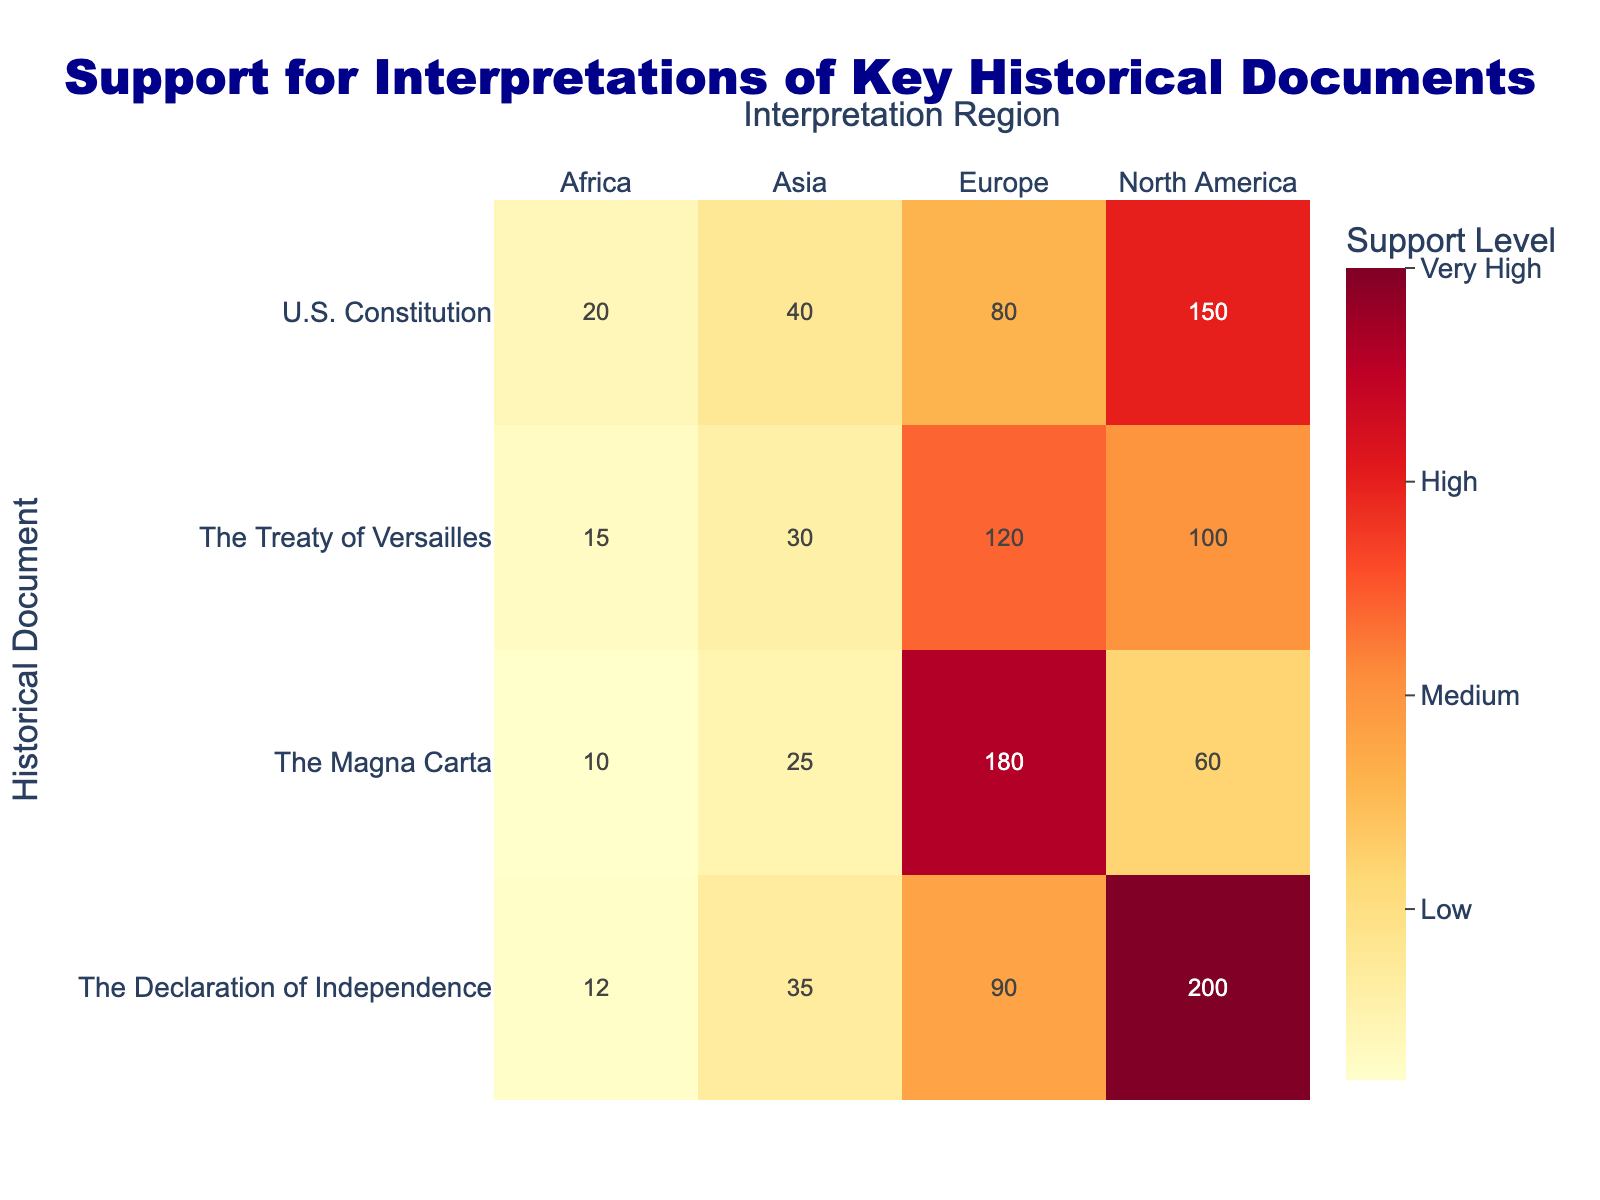What is the highest level of support for the U.S. Constitution, and which region is it from? The highest support for the U.S. Constitution is 150, coming from North America. This can be found directly in the table under the Support for Interpretation column corresponding to the U.S. Constitution row.
Answer: 150, North America What is the total support for the Magna Carta across all regions? To find the total support for the Magna Carta, we sum the support values from all regions: 60 (North America) + 180 (Europe) + 25 (Asia) + 10 (Africa) = 275.
Answer: 275 Is there more support for The Declaration of Independence in Asia than in Africa? The support for The Declaration of Independence in Asia is 35, while in Africa it is 12. Since 35 is greater than 12, the answer to the question is yes.
Answer: Yes What is the average support for the Treaty of Versailles across the four regions? The support values for the Treaty of Versailles are: 100 (North America), 120 (Europe), 30 (Asia), and 15 (Africa). The total is 100 + 120 + 30 + 15 = 265. There are 4 regions, so the average is 265 / 4 = 66.25.
Answer: 66.25 Which historical document has the most opposition to interpretation in North America? The historical document with the most opposition in North America is The Treaty of Versailles, which has an opposition value of 60. We compare the opposition values for all documents in North America and find that 60 is the highest.
Answer: The Treaty of Versailles What is the difference in support for interpretations of the U.S. Constitution and The Magna Carta in Europe? In Europe, the support for the U.S. Constitution is 80 and for The Magna Carta is 180. The difference is calculated as 180 - 80 = 100.
Answer: 100 Are there more instances of support or opposition to The Magna Carta across all regions combined? First, we total the support of The Magna Carta: 60 + 180 + 25 + 10 = 275. Then, we total the opposition: 20 + 40 + 10 + 5 = 75. Since 275 (support) is greater than 75 (opposition), the answer is more support.
Answer: More support Which region shows the lowest support for The Declaration of Independence? The support values for The Declaration of Independence are: 200 (North America), 90 (Europe), 35 (Asia), and 12 (Africa). The lowest value is 12, which corresponds to Africa.
Answer: Africa What is the combined support for all documents in Asia? To find the combined support for all documents in Asia, we add: U.S. Constitution (40) + Treaty of Versailles (30) + Magna Carta (25) + Declaration of Independence (35) = 130.
Answer: 130 